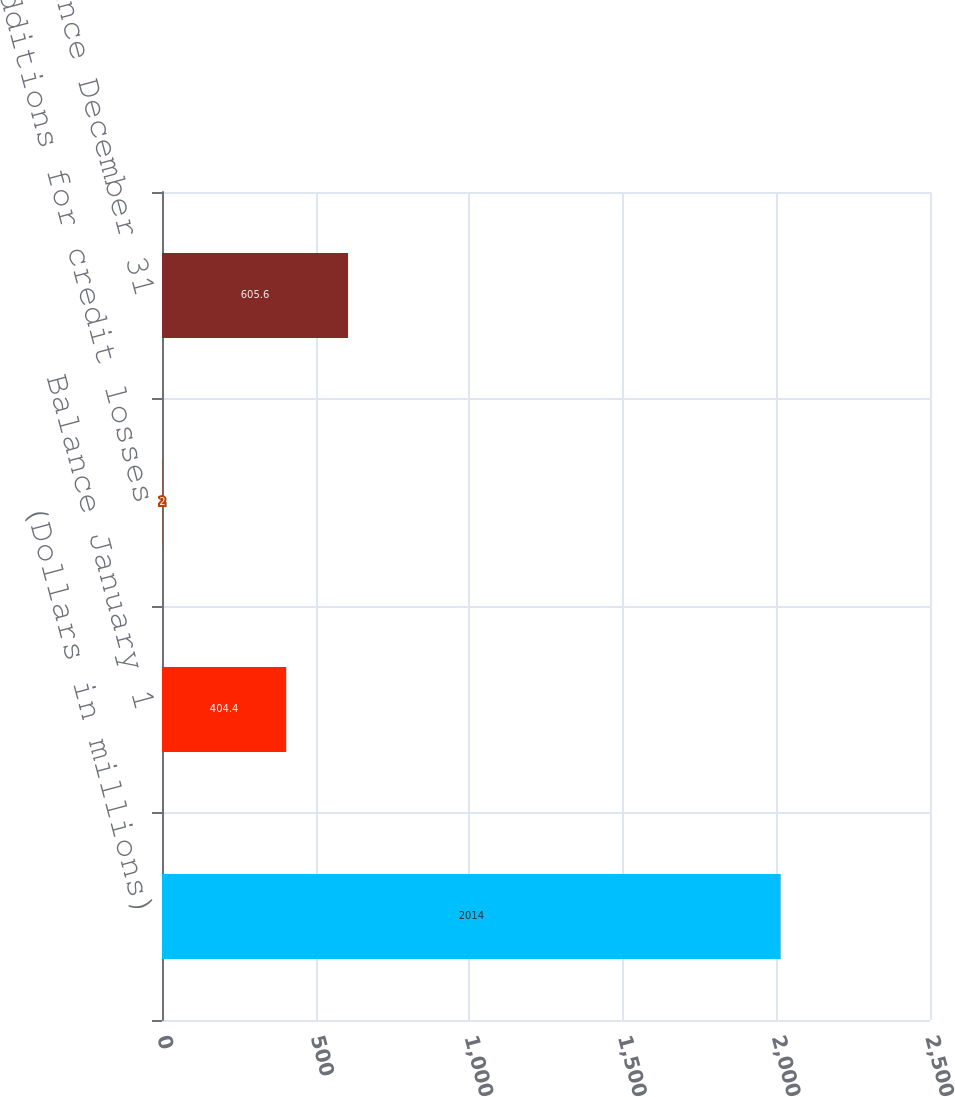Convert chart. <chart><loc_0><loc_0><loc_500><loc_500><bar_chart><fcel>(Dollars in millions)<fcel>Balance January 1<fcel>Additions for credit losses<fcel>Balance December 31<nl><fcel>2014<fcel>404.4<fcel>2<fcel>605.6<nl></chart> 